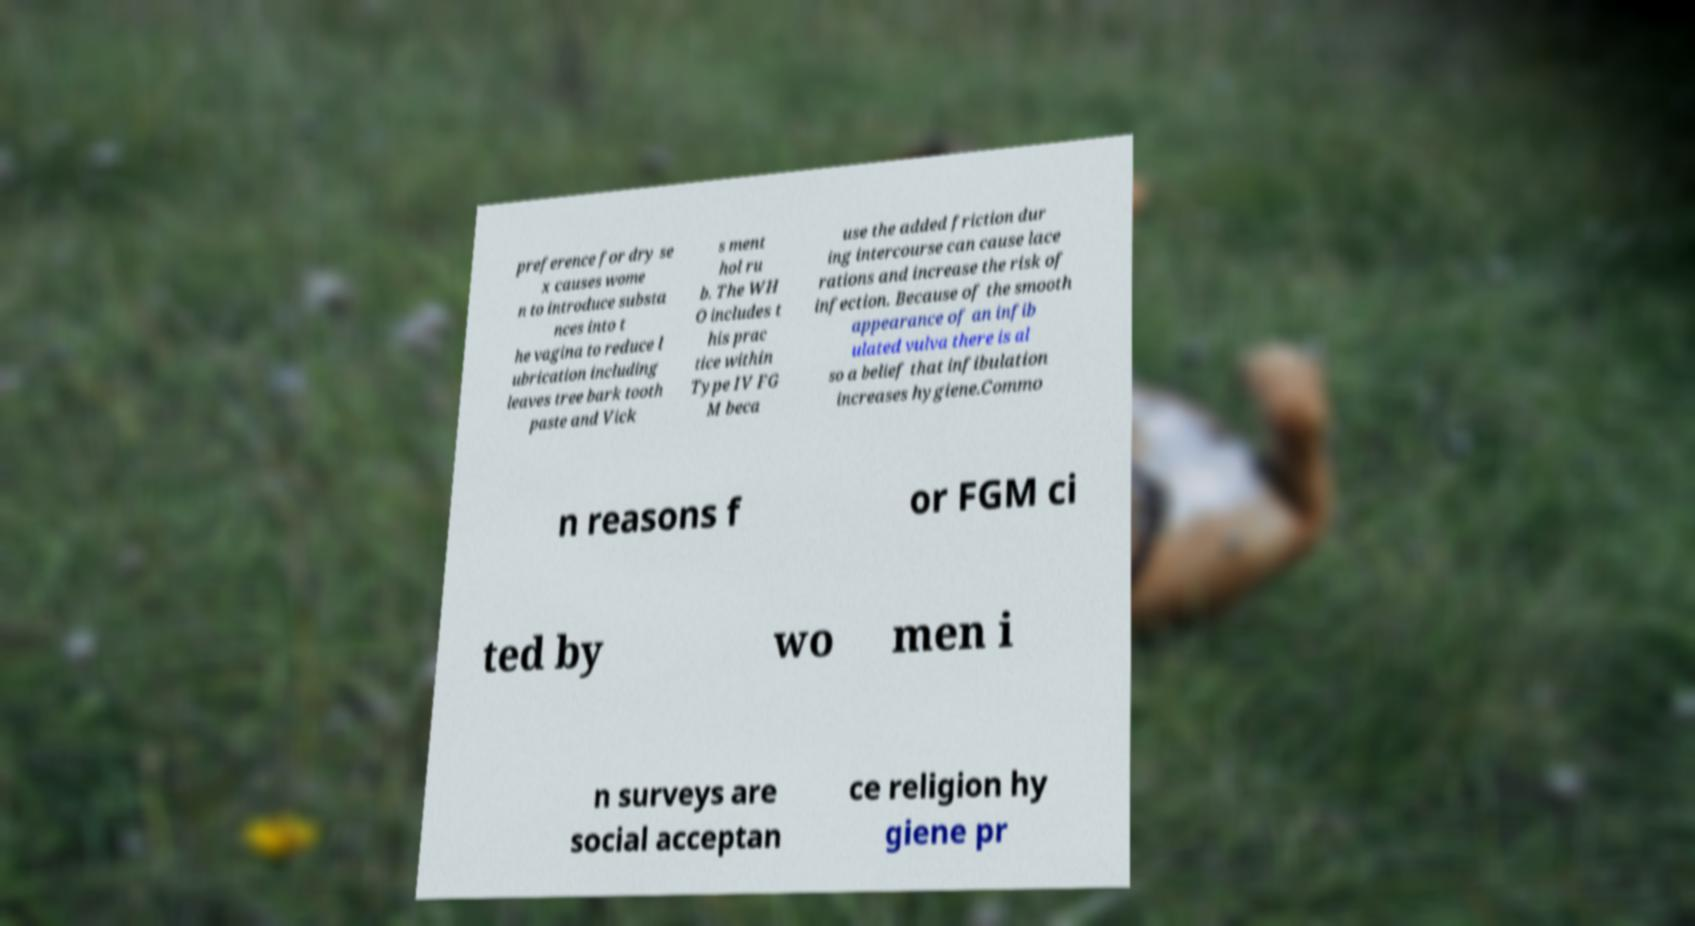Can you accurately transcribe the text from the provided image for me? preference for dry se x causes wome n to introduce substa nces into t he vagina to reduce l ubrication including leaves tree bark tooth paste and Vick s ment hol ru b. The WH O includes t his prac tice within Type IV FG M beca use the added friction dur ing intercourse can cause lace rations and increase the risk of infection. Because of the smooth appearance of an infib ulated vulva there is al so a belief that infibulation increases hygiene.Commo n reasons f or FGM ci ted by wo men i n surveys are social acceptan ce religion hy giene pr 